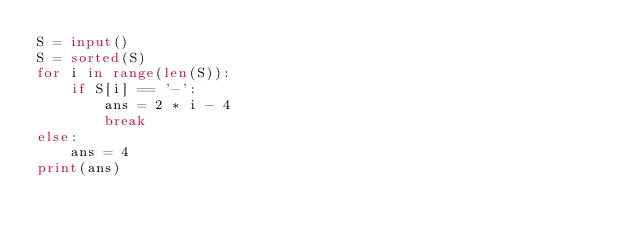Convert code to text. <code><loc_0><loc_0><loc_500><loc_500><_Python_>S = input()
S = sorted(S)
for i in range(len(S)):
    if S[i] == '-':
        ans = 2 * i - 4
        break
else:
    ans = 4
print(ans)
</code> 